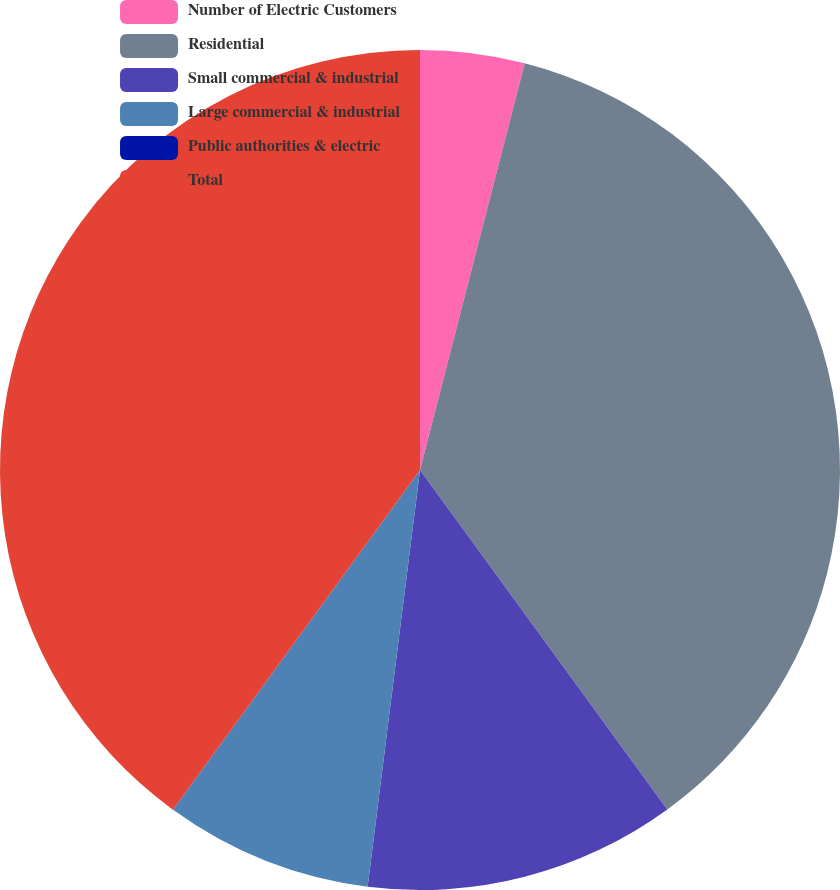Convert chart. <chart><loc_0><loc_0><loc_500><loc_500><pie_chart><fcel>Number of Electric Customers<fcel>Residential<fcel>Small commercial & industrial<fcel>Large commercial & industrial<fcel>Public authorities & electric<fcel>Total<nl><fcel>4.01%<fcel>35.97%<fcel>12.01%<fcel>8.01%<fcel>0.01%<fcel>39.99%<nl></chart> 